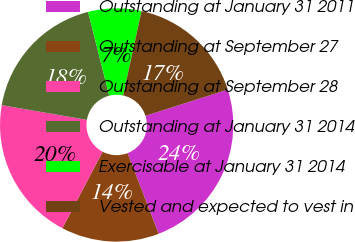Convert chart to OTSL. <chart><loc_0><loc_0><loc_500><loc_500><pie_chart><fcel>Outstanding at January 31 2011<fcel>Outstanding at September 27<fcel>Outstanding at September 28<fcel>Outstanding at January 31 2014<fcel>Exercisable at January 31 2014<fcel>Vested and expected to vest in<nl><fcel>24.04%<fcel>13.57%<fcel>20.01%<fcel>18.34%<fcel>7.37%<fcel>16.67%<nl></chart> 